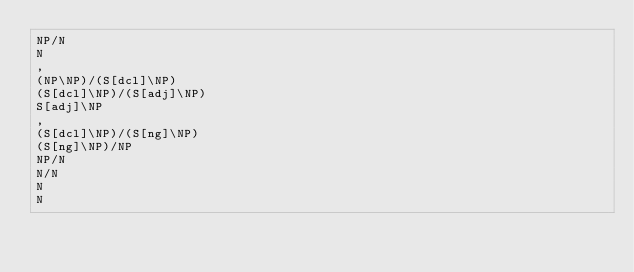Convert code to text. <code><loc_0><loc_0><loc_500><loc_500><_C_>NP/N
N
,
(NP\NP)/(S[dcl]\NP)
(S[dcl]\NP)/(S[adj]\NP)
S[adj]\NP
,
(S[dcl]\NP)/(S[ng]\NP)
(S[ng]\NP)/NP
NP/N
N/N
N
N
</code> 